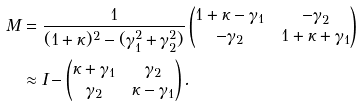<formula> <loc_0><loc_0><loc_500><loc_500>M & = \frac { 1 } { ( 1 + \kappa ) ^ { 2 } - ( \gamma _ { 1 } ^ { 2 } + \gamma _ { 2 } ^ { 2 } ) } \begin{pmatrix} 1 + \kappa - \gamma _ { 1 } & - \gamma _ { 2 } \\ - \gamma _ { 2 } & 1 + \kappa + \gamma _ { 1 } \end{pmatrix} \\ & \approx I - \begin{pmatrix} \kappa + \gamma _ { 1 } & \gamma _ { 2 } \\ \gamma _ { 2 } & \kappa - \gamma _ { 1 } \end{pmatrix} .</formula> 